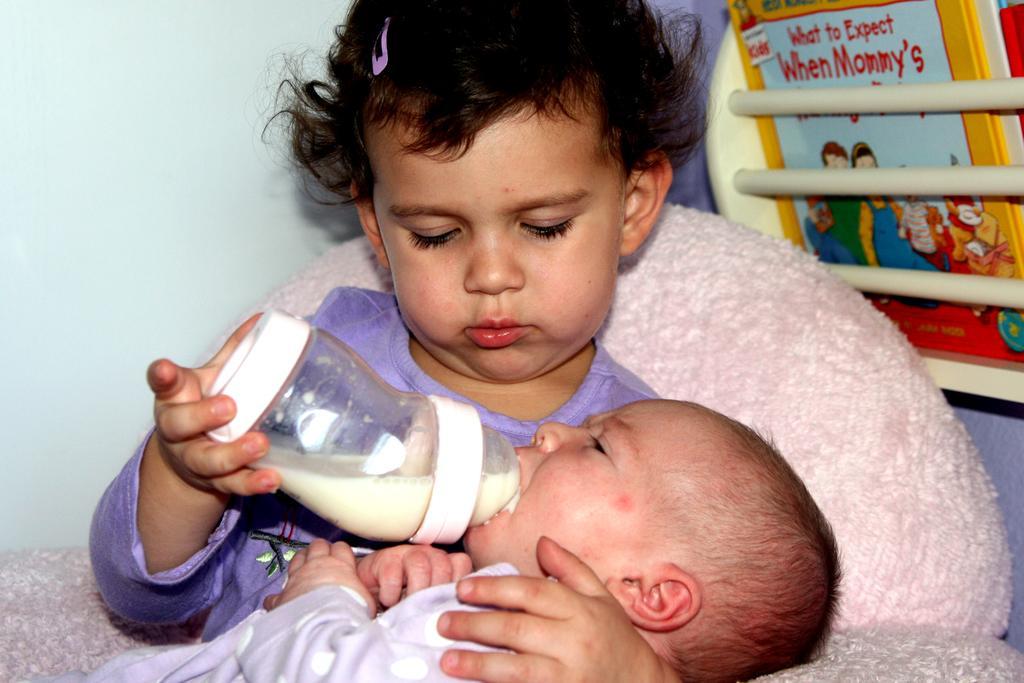How would you summarize this image in a sentence or two? In this picture we can see two children, here we can see a bottle with milk in it and in the background we can see a wall, book and some objects. 